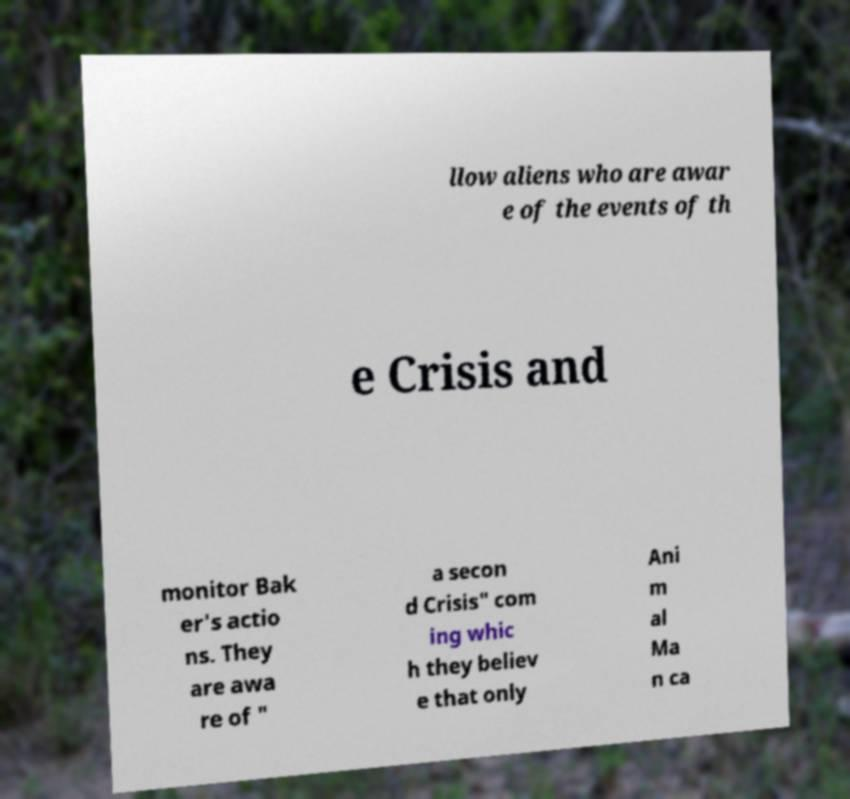I need the written content from this picture converted into text. Can you do that? llow aliens who are awar e of the events of th e Crisis and monitor Bak er's actio ns. They are awa re of " a secon d Crisis" com ing whic h they believ e that only Ani m al Ma n ca 